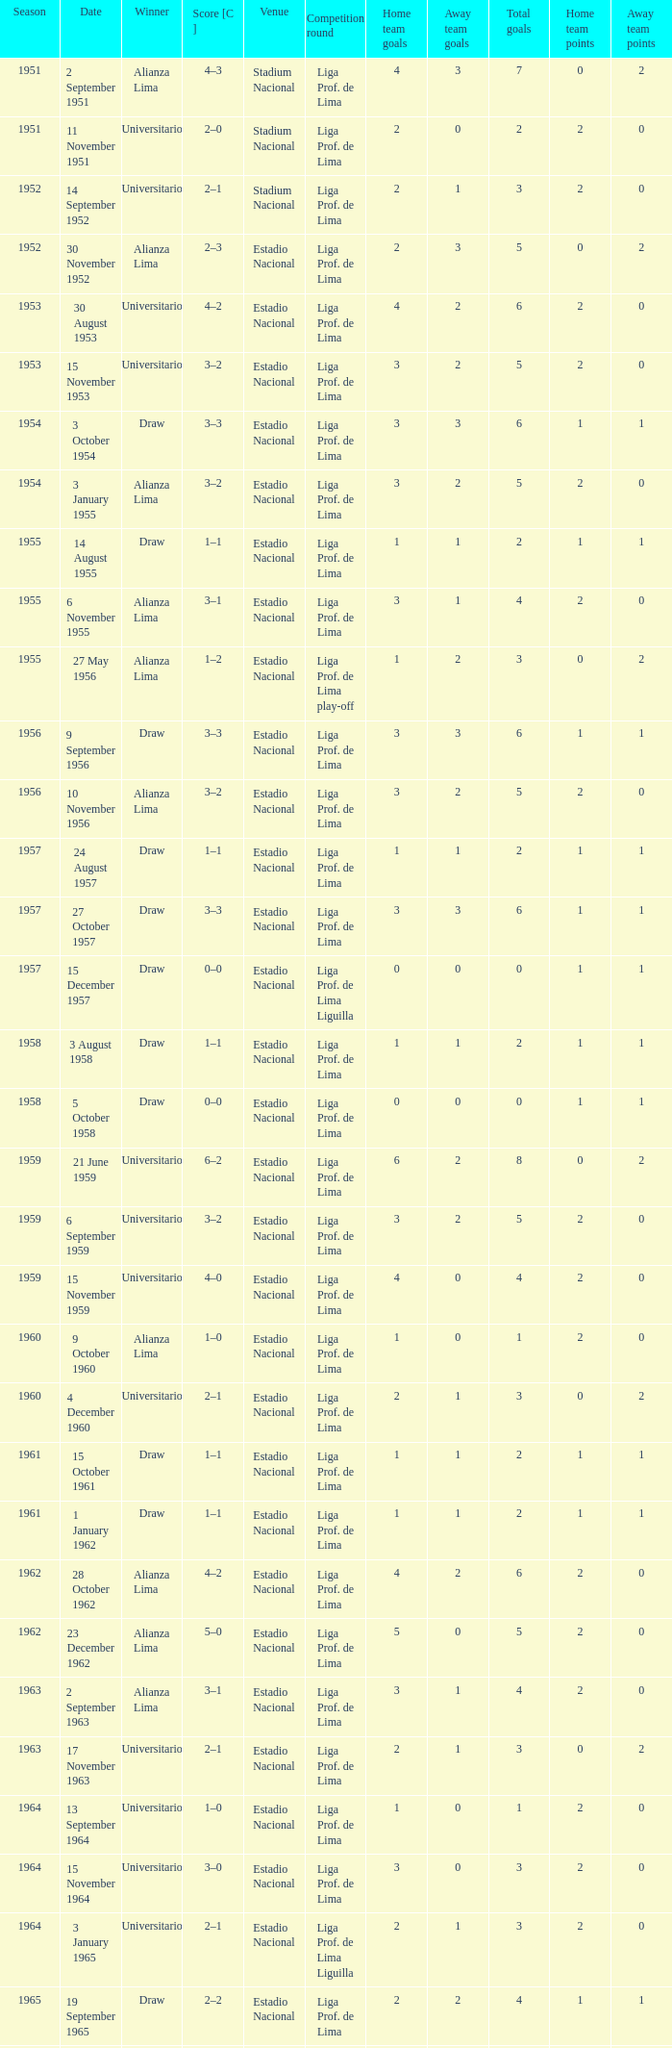What is the score of the event that Alianza Lima won in 1965? 1–0. 